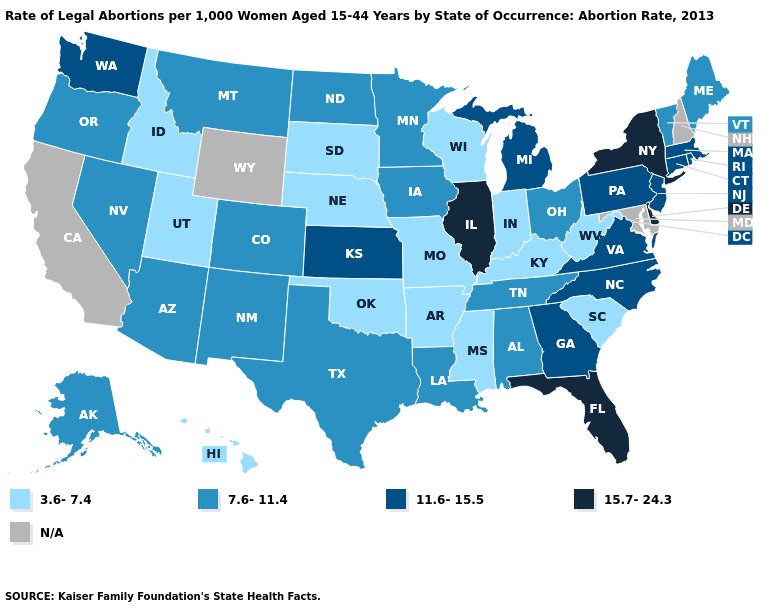How many symbols are there in the legend?
Be succinct. 5. What is the value of New Mexico?
Give a very brief answer. 7.6-11.4. How many symbols are there in the legend?
Concise answer only. 5. What is the highest value in the MidWest ?
Short answer required. 15.7-24.3. Name the states that have a value in the range N/A?
Quick response, please. California, Maryland, New Hampshire, Wyoming. What is the value of New York?
Short answer required. 15.7-24.3. Among the states that border Kentucky , which have the highest value?
Concise answer only. Illinois. Name the states that have a value in the range N/A?
Give a very brief answer. California, Maryland, New Hampshire, Wyoming. What is the lowest value in states that border Missouri?
Be succinct. 3.6-7.4. What is the value of Texas?
Short answer required. 7.6-11.4. Among the states that border Georgia , which have the highest value?
Give a very brief answer. Florida. Among the states that border Kentucky , does Illinois have the highest value?
Answer briefly. Yes. Which states have the lowest value in the USA?
Keep it brief. Arkansas, Hawaii, Idaho, Indiana, Kentucky, Mississippi, Missouri, Nebraska, Oklahoma, South Carolina, South Dakota, Utah, West Virginia, Wisconsin. What is the highest value in states that border Virginia?
Short answer required. 11.6-15.5. 